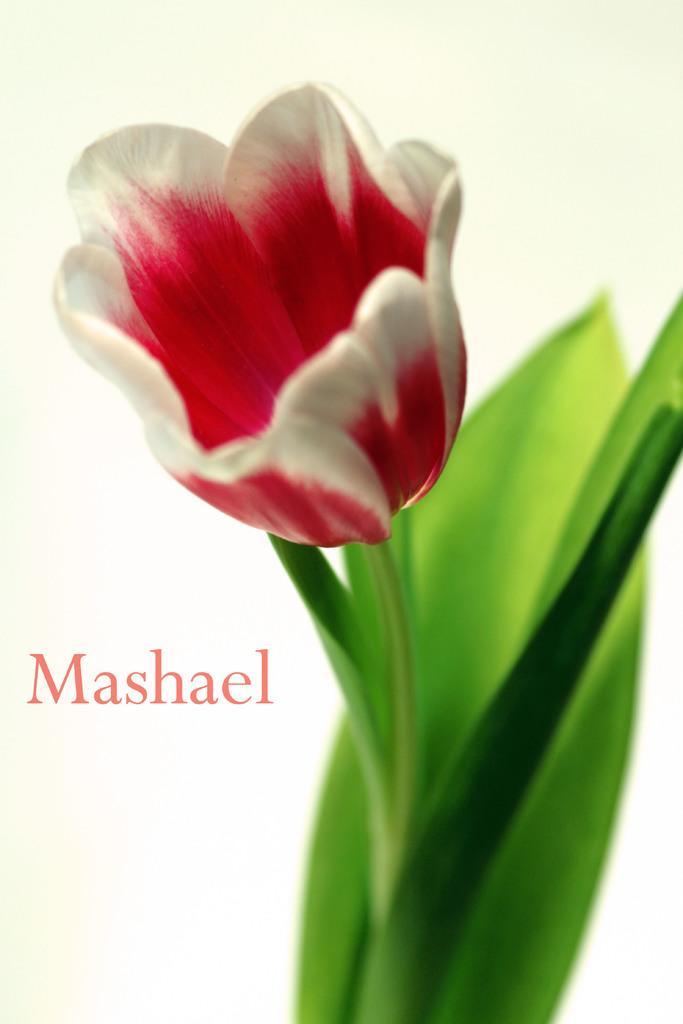Describe this image in one or two sentences. Here we can see a flower and leaves and on the left there is a text. 